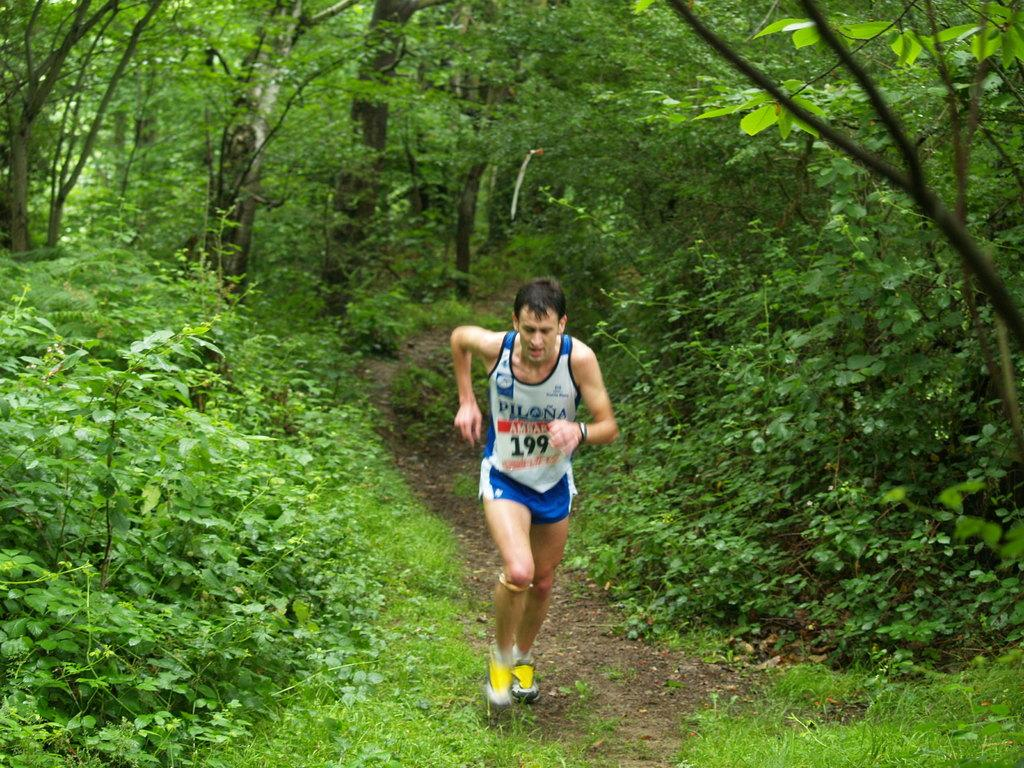Who is the main subject in the image? There is a man in the image. What is the man doing in the image? The man is running on the ground. What can be seen in the background of the image? There are trees and plants in the background of the image. What type of pen is the man holding while running in the image? There is no pen present in the image; the man is running without holding any object. 